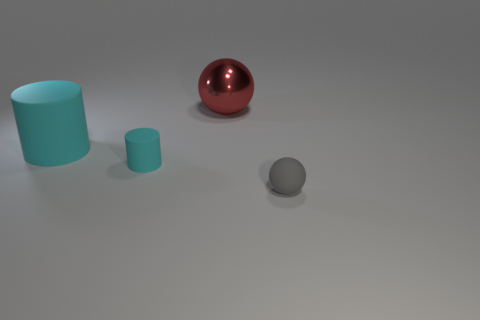Add 1 large brown balls. How many objects exist? 5 Subtract all tiny cyan things. Subtract all cyan metal objects. How many objects are left? 3 Add 1 small gray rubber objects. How many small gray rubber objects are left? 2 Add 4 small green matte cylinders. How many small green matte cylinders exist? 4 Subtract 0 purple blocks. How many objects are left? 4 